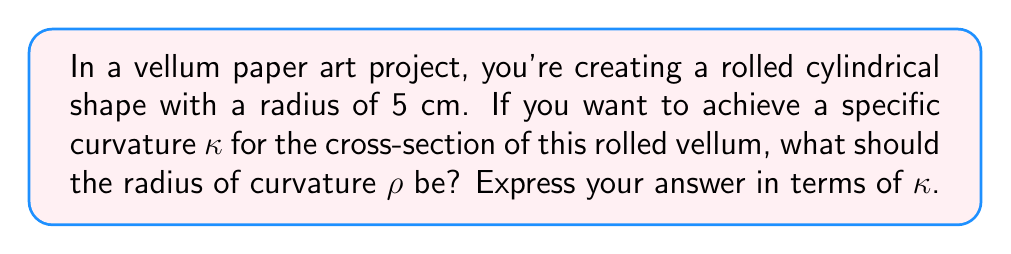Give your solution to this math problem. To solve this problem, we need to understand the relationship between curvature (κ) and radius of curvature (ρ). In differential geometry, the curvature is defined as the reciprocal of the radius of curvature:

$$ κ = \frac{1}{ρ} $$

Therefore, to find the radius of curvature in terms of κ, we simply need to rearrange this equation:

$$ ρ = \frac{1}{κ} $$

This means that the radius of curvature is inversely proportional to the curvature. As the curvature increases, the radius of curvature decreases, and vice versa.

In the context of our vellum paper art project:

1. The cylinder has a radius of 5 cm, but this is not directly related to the curvature we're calculating.
2. The curvature κ is given (although not specified numerically), and we need to express ρ in terms of it.
3. We can directly use the formula ρ = 1/κ to express the radius of curvature.

[asy]
import geometry;

draw(circle((0,0),5), blue);
draw((0,0)--(5,0), red, Arrow);
label("r = 5 cm", (2.5,0.5), N);
label("κ", (5,0), E);
label("ρ = 1/κ", (-2,-2), SW);
</asy]

This diagram illustrates the circular cross-section of the rolled vellum, with the radius and curvature indicated.
Answer: $ρ = \frac{1}{κ}$ 